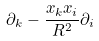<formula> <loc_0><loc_0><loc_500><loc_500>\partial _ { k } - { \frac { x _ { k } x _ { i } } { R ^ { 2 } } } \partial _ { i }</formula> 